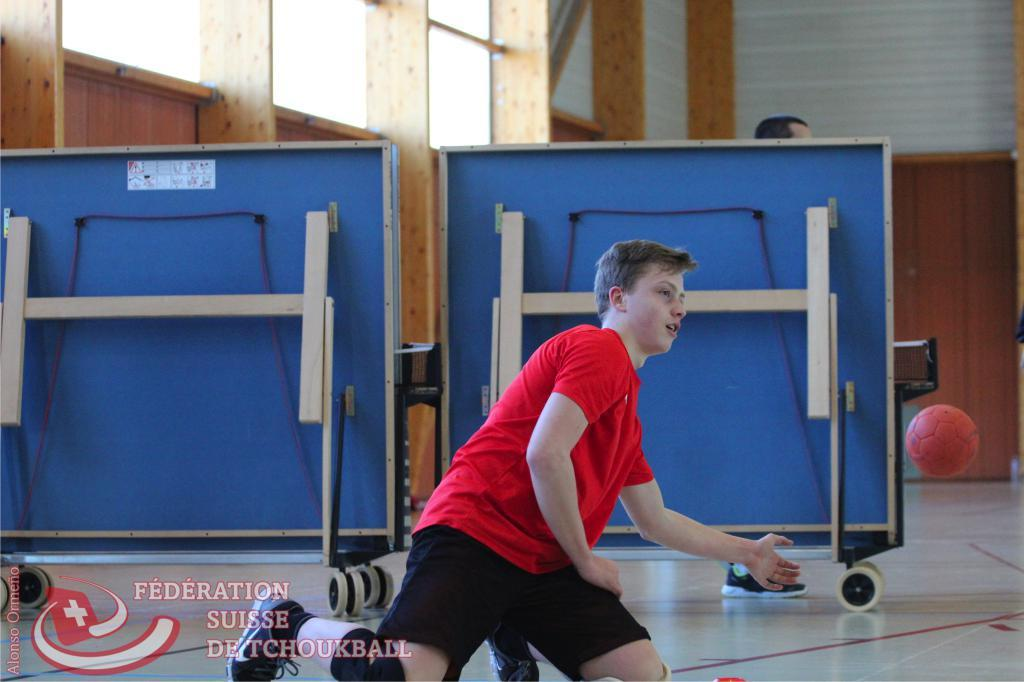Provide a one-sentence caption for the provided image. A young man in a red shirt is playing a sport with a red ball for the Federation Suiise Detchoukball. 